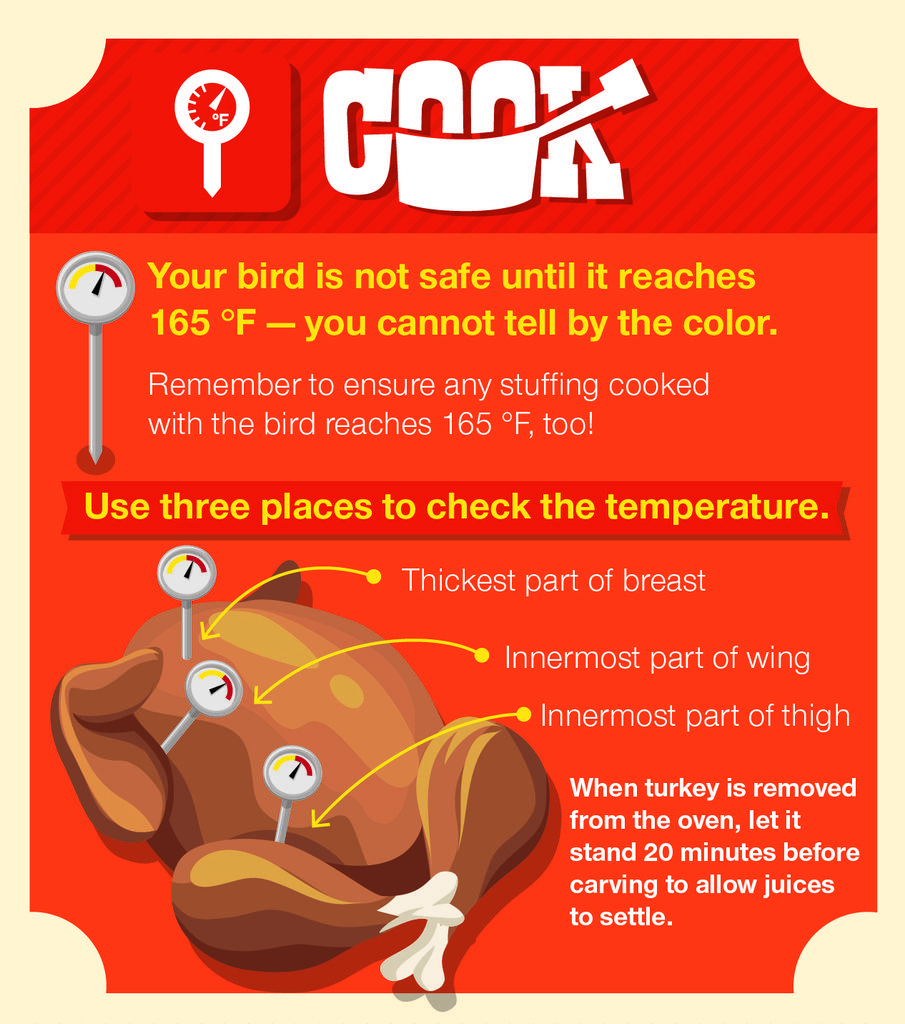What type of visual is the image? The image is a poster. What can be found on the poster besides the visual elements? There is text on the poster. What animal is depicted on the poster? There is a chicken depicted on the poster. What type of insect can be seen crawling on the chicken in the image? There is no insect present on the chicken in the image. What is the income of the person who created the poster? The income of the person who created the poster is not mentioned or visible in the image. 